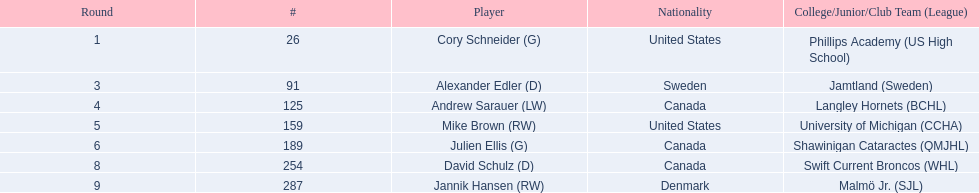What are the designations of the colleges and jr leagues the sportspeople attended? Phillips Academy (US High School), Jamtland (Sweden), Langley Hornets (BCHL), University of Michigan (CCHA), Shawinigan Cataractes (QMJHL), Swift Current Broncos (WHL), Malmö Jr. (SJL). Which sportsperson played for the langley hornets? Andrew Sarauer (LW). 